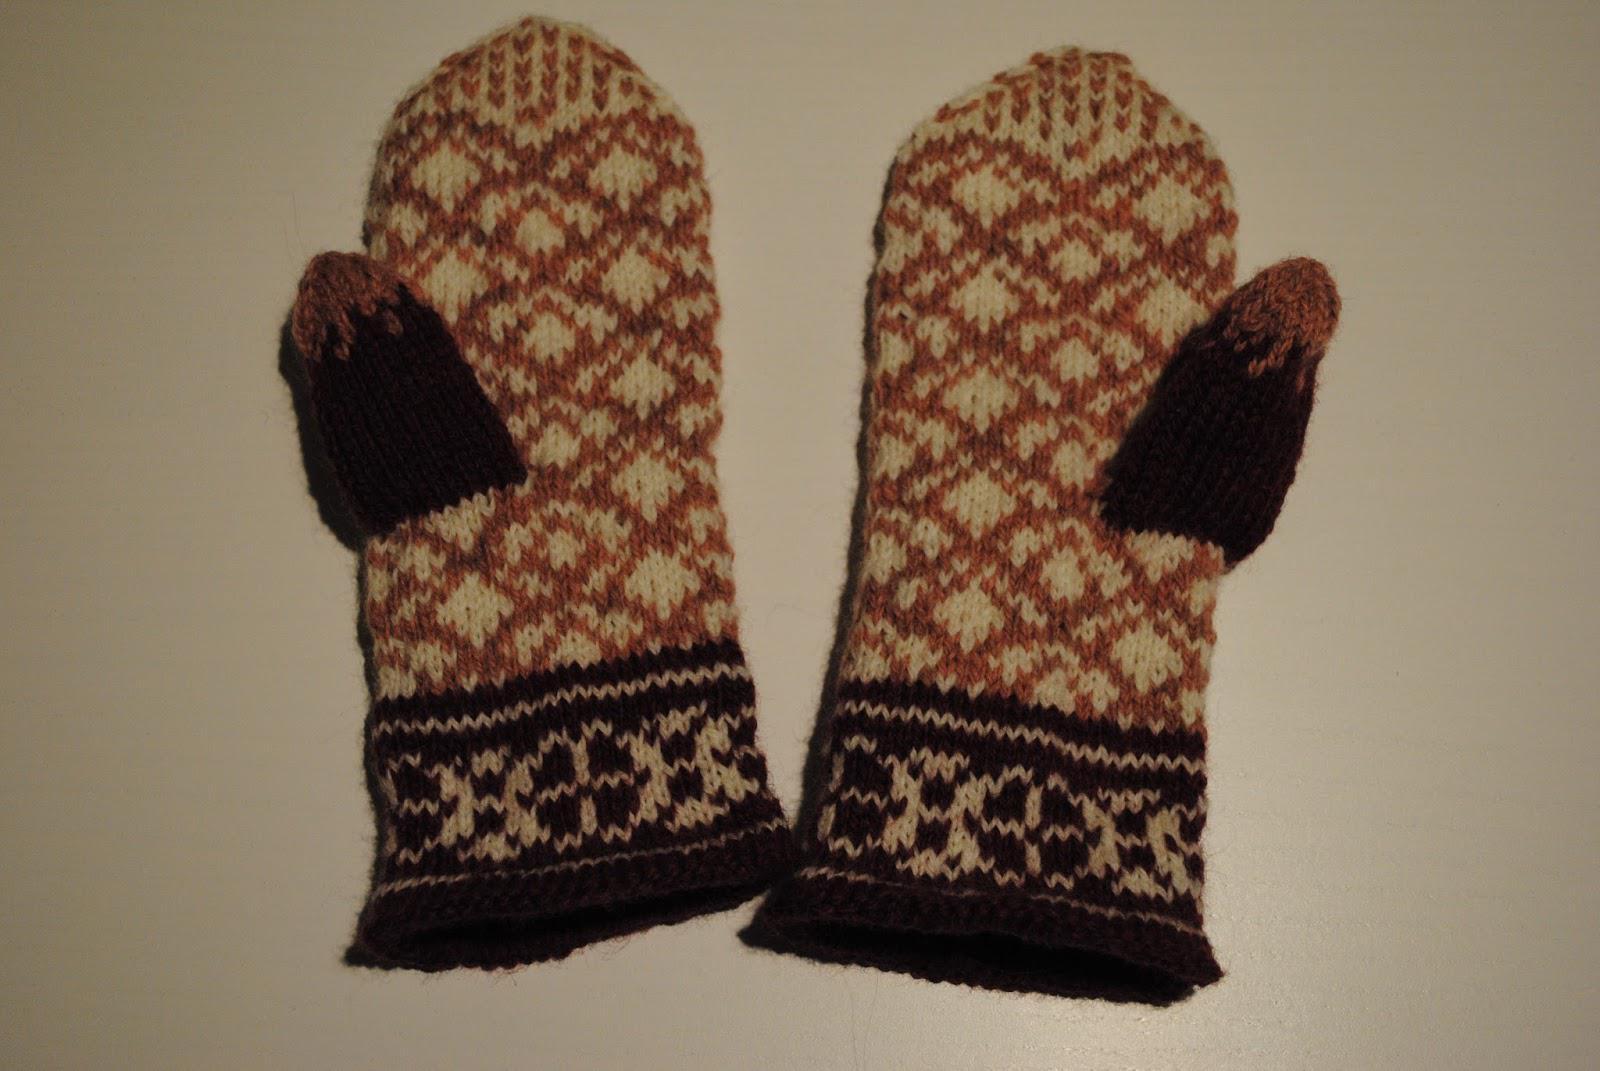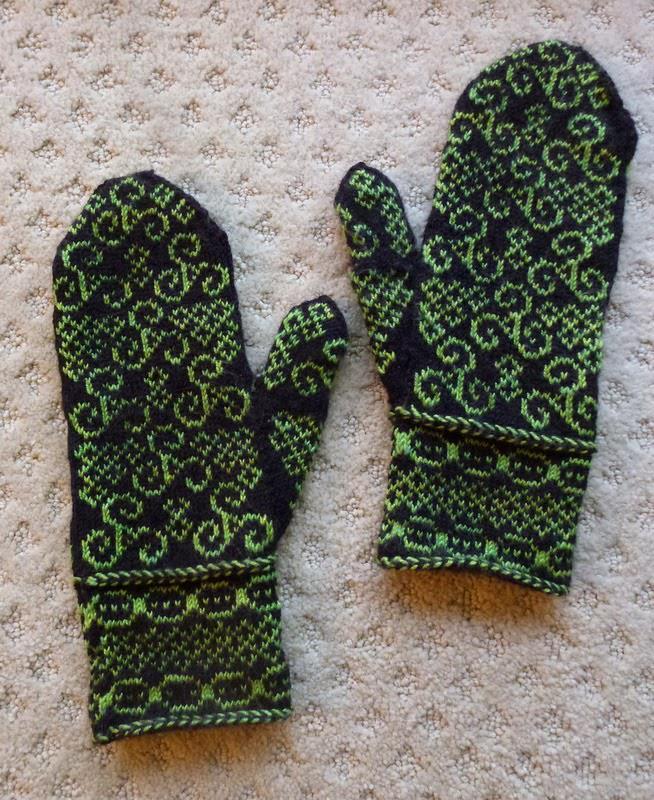The first image is the image on the left, the second image is the image on the right. Considering the images on both sides, is "Each image contains a pair of mittens, and one pair of mittens has an animal figure on the front-facing mitten." valid? Answer yes or no. No. The first image is the image on the left, the second image is the image on the right. Analyze the images presented: Is the assertion "The left and right image contains the same number of mittens with at least one set green." valid? Answer yes or no. Yes. 